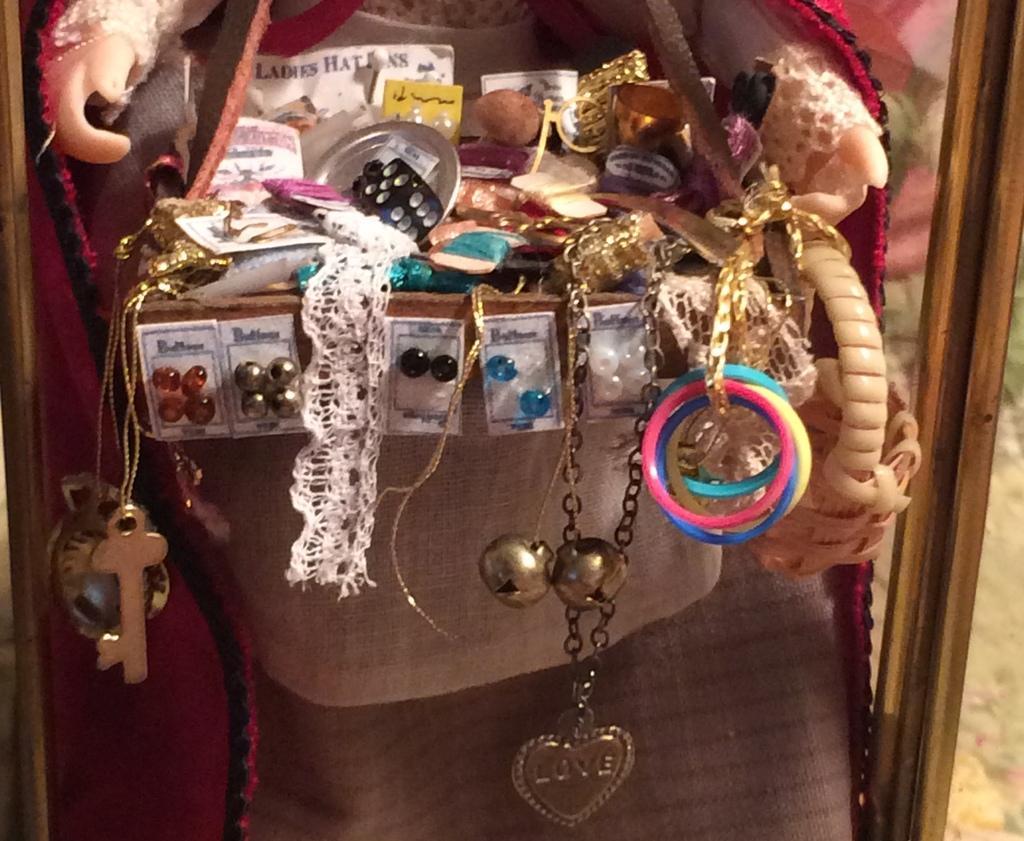How would you summarize this image in a sentence or two? In this picture, we see a grey bag containing the earrings, bands in different colors, bracelet, locket, key and a small basket. We even see some other objects in the bag. Behind that, we see a doll. On the right side, we see the wooden stick or a pole. 